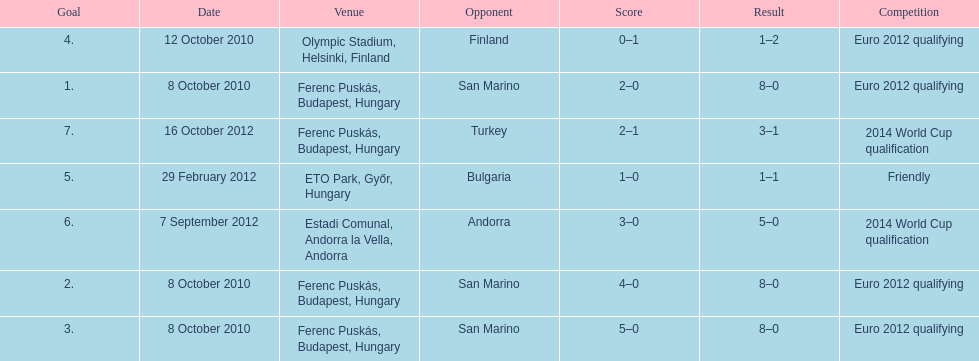How many goals were scored at the euro 2012 qualifying competition? 12. 